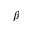Convert formula to latex. <formula><loc_0><loc_0><loc_500><loc_500>\beta</formula> 